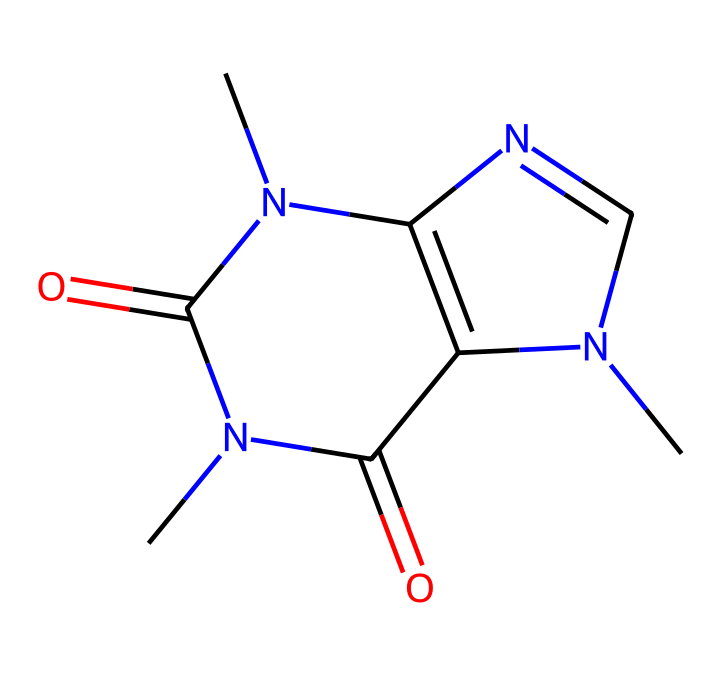What is the common name of the chemical represented by this SMILES? The SMILES corresponds to a chemical structure recognized as caffeine, which is commonly known due to its prevalence in energy drinks and coffee.
Answer: caffeine How many nitrogen atoms are present in the compound? By analyzing the SMILES representation, we can count the nitrogen present: there are three 'N' symbols indicating three nitrogen atoms in the chemical structure.
Answer: three What is the total number of carbon atoms in this structure? In the structure, we can identify the carbon locations in the SMILES. Counting all the carbon atoms results in a total of eight carbon atoms present in this molecule.
Answer: eight What type of functional group is primarily present in this chemical structure? The structure features imide functional groups, which is indicated by the carbonyl (C=O) connected to nitrogen. The presence of these groups is what categorizes it to be an imide.
Answer: imide Does this compound contain any stereocenters? Upon examining the structure for stereocenters, we find that there are no carbon atoms bound to four different substituents, indicating that there are no stereocenters present in this compound.
Answer: no How many double bonds are in the chemical structure? Analyzing the immediate representation, the presence of double bonds can be determined by the '=' signs in the SMILES notation, which indicates there are two double bonds present.
Answer: two What makes this compound classified as a stimulant? The presence of the nitrogen atoms contributes to its classification as a stimulant because these atoms are part of the structure known to affect the central nervous system, particularly through their role in neurotransmitter modulation.
Answer: nitrogen 